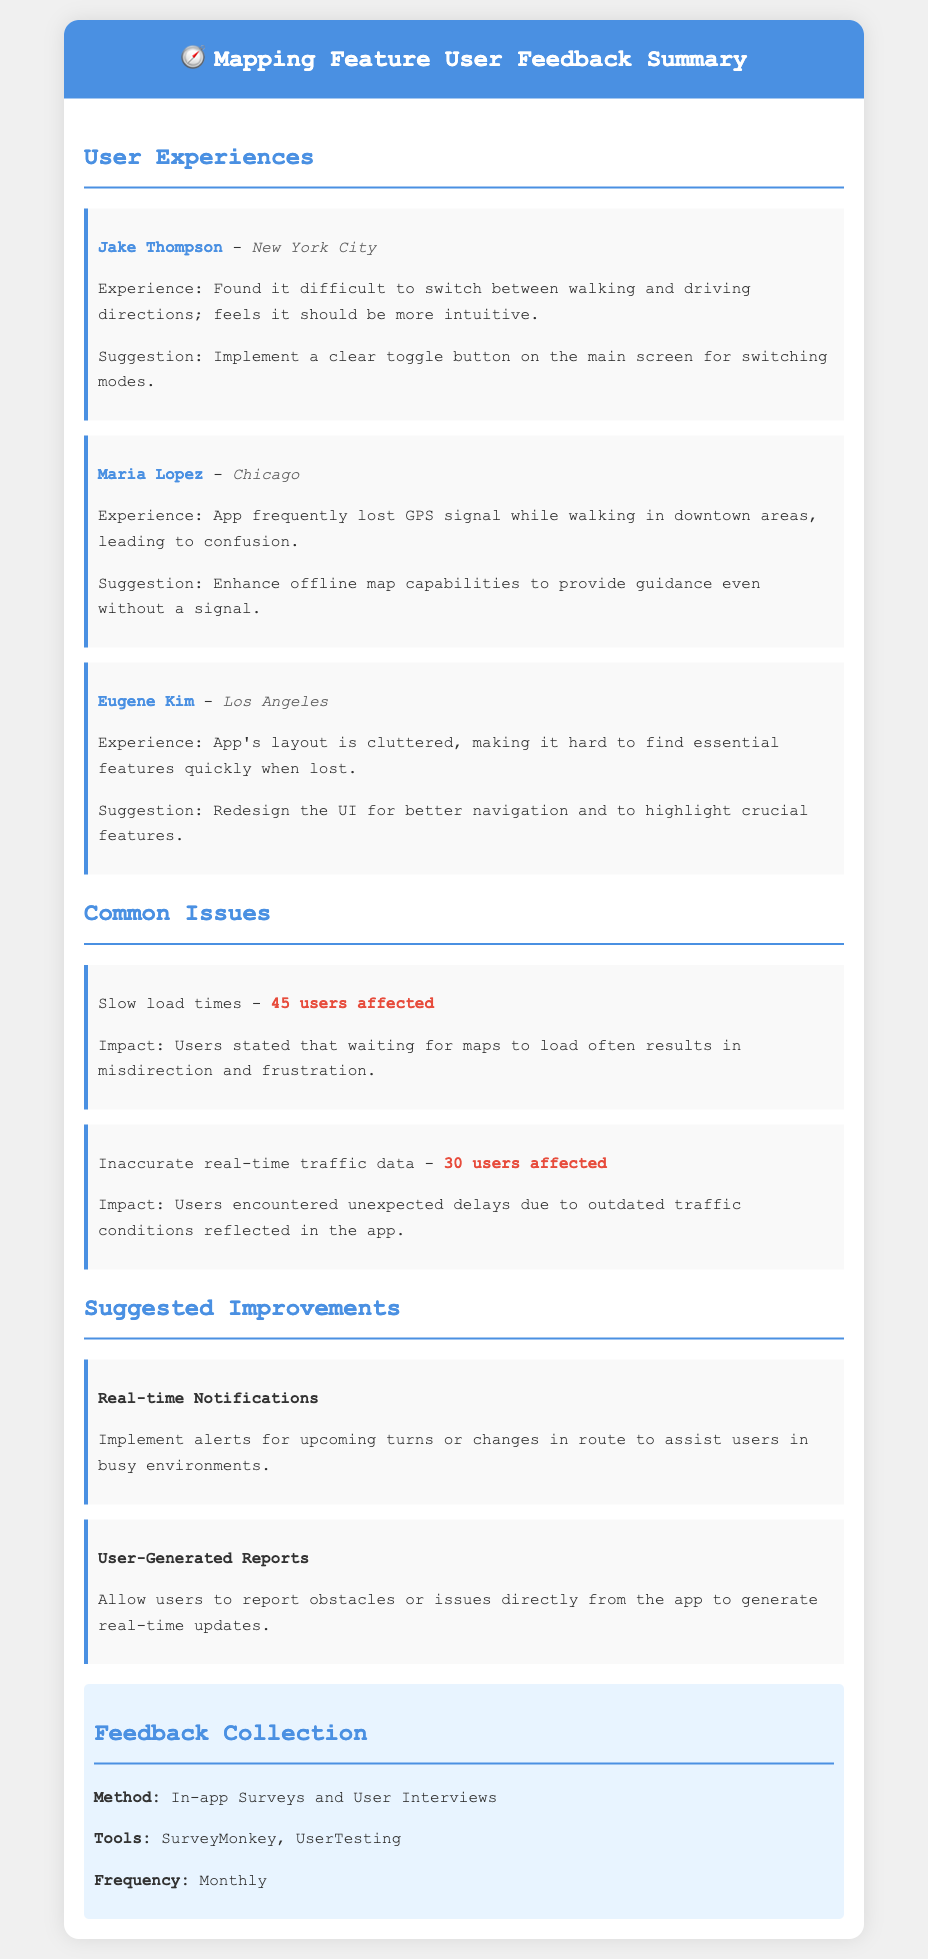What is the name of the user who found it difficult to switch between walking and driving directions? Jake Thompson expressed difficulty in switching directions.
Answer: Jake Thompson How many users reported slow load times? The document specifies that 45 users are affected by this issue.
Answer: 45 users What is one of the suggested improvements for the mapping feature? The document lists several suggestions including implementing real-time notifications.
Answer: Real-time Notifications Which city did Maria Lopez provide feedback from? The document states that her feedback is from Chicago.
Answer: Chicago What is the impact of inaccurate real-time traffic data? Users encountered unexpected delays due to outdated traffic conditions.
Answer: Unexpected delays What tool is mentioned for collecting user feedback? The document lists SurveyMonkey as one of the tools used for feedback collection.
Answer: SurveyMonkey What is the frequency of the feedback collection mentioned? The document indicates that feedback collection occurs monthly.
Answer: Monthly What is a common issue faced by users related to GPS? The document describes that the app frequently lost GPS signal while walking.
Answer: Lost GPS signal How many users experienced the issue related to inaccurate real-time traffic data? The document specifies that 30 users were affected by this issue.
Answer: 30 users 